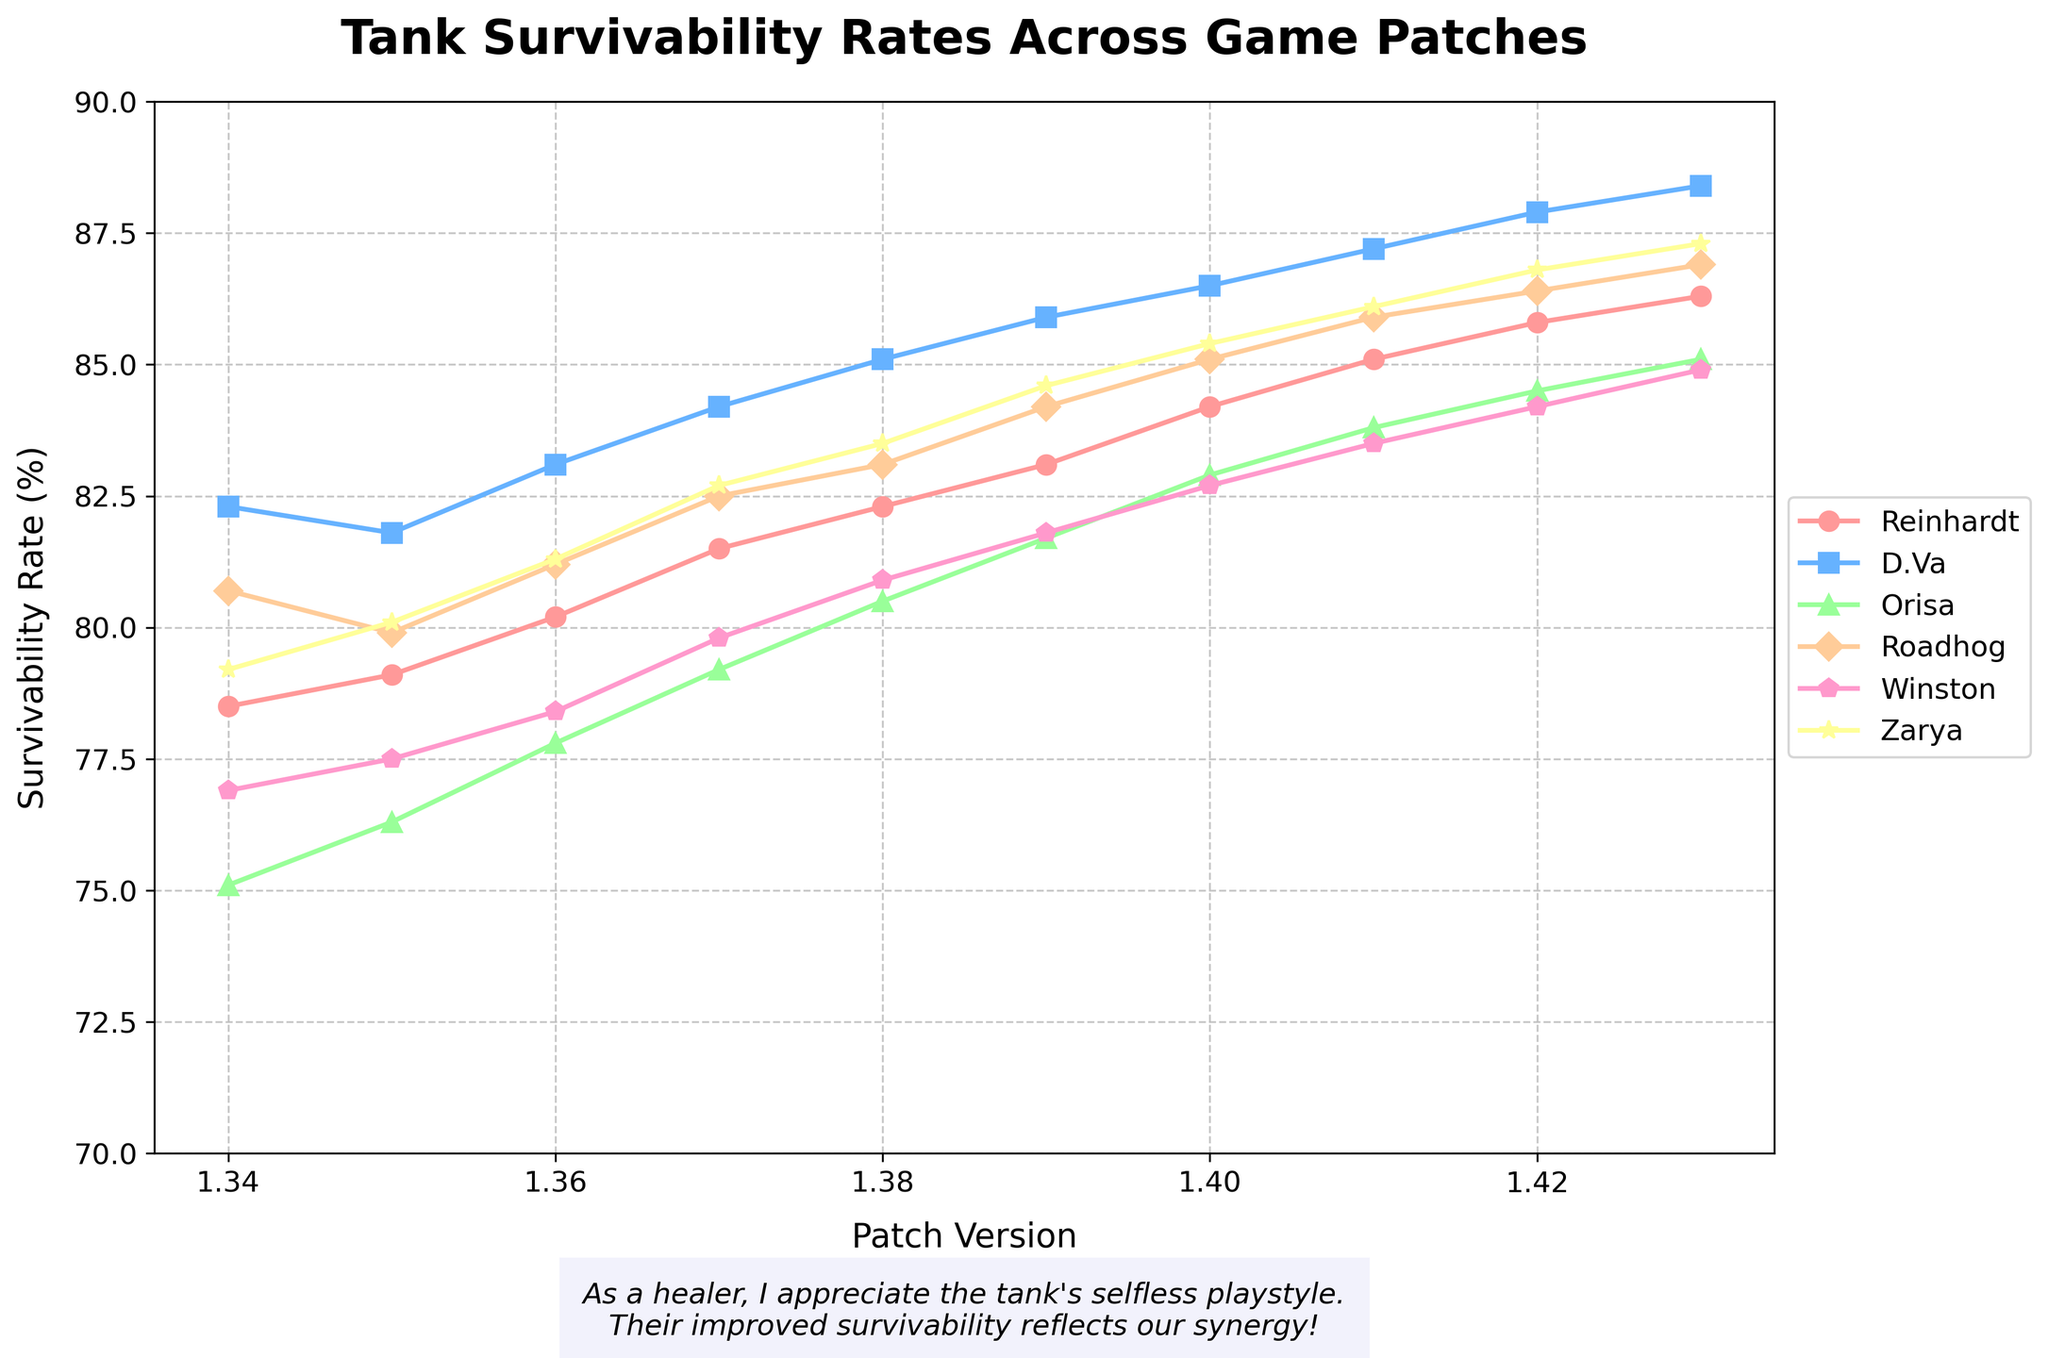Which tank character shows the greatest improvement in survivability from patch 1.34 to 1.43? To determine the tank character that shows the greatest improvement, we need to calculate the difference between the survivability rates in patch 1.43 and patch 1.34 for each character. The increases are: Reinhardt (86.3 - 78.5 = 7.8), D.Va (88.4 - 82.3 = 6.1), Orisa (85.1 - 75.1 = 10.0), Roadhog (86.9 - 80.7 = 6.2), Winston (84.9 - 76.9 = 8.0), Zarya (87.3 - 79.2 = 8.1). Therefore, Orisa shows the greatest improvement.
Answer: Orisa Between patches 1.35 and 1.40, which tank had the most consistent survivability rate increases (lowest variance)? To find the most consistent tank, we need to look at the changes in survivability rates between each consecutive patch from 1.35 to 1.40 for each tank and find the one with the smallest range (highest consistency). The differences for each tank are as follows: 
Reinhardt: 79.1, 80.2, 81.5, 82.3, 84.2 (variance = [(0.9+1.3+0.8+1.9)/4])
D.Va: 81.8, 83.1, 84.2, 85.1, 86.5 (variance = [(1.3+1.1+0.9+1.4)/4])
Orisa: 76.3, 77.8, 79.2, 80.5, 82.9 (variance = [(1.5+1.4+1.3+2.4)/4])
Roadhog: 79.9, 81.2, 82.5, 83.1, 85.1 (variance = [(1.3+1.3+0.6+2.0)/4])
Winston: 77.5, 78.4, 79.8, 80.9, 82.7 (variance = [(0.9+1.4+1.1+1.8)/4])
Zarya: 80.1, 81.3, 82.7, 83.5, 85.4 (variance = [(1.2+1.4+0.8+1.9)/4])
D.Va had the most consistent increases.
Answer: D.Va Which tank had the highest survivability rate in patch 1.42? To find this, simply look at the survivability rates for all tanks in patch 1.42: Reinhardt (85.8), D.Va (87.9), Orisa (84.5), Roadhog (86.4), Winston (84.2), Zarya (86.8). D.Va has the highest survivability rate.
Answer: D.Va What is the average survivability rate of Winston across all patches? Calculate the sum of Winston's survivability rates over all patches and then divide by the number of patches: (76.9 + 77.5 + 78.4 + 79.8 + 80.9 + 81.8 + 82.7 + 83.5 + 84.2 + 84.9) / 10. The sum is 810.6, so the average is 81.06.
Answer: 81.06 How did Roadhog's survivability rate change from patch 1.36 to 1.37 compared to D.Va's? Check the rate changes for both in those patches: Roadhog's increased from 81.2 to 82.5 (1.3), whereas D.Va's increased from 83.1 to 84.2 (1.1). Roadhog had a greater change.
Answer: Roadhog Which color line represents Zarya's survivability rate in the figure? In the figure, Zarya's line is represented by the color yellow.
Answer: Yellow 